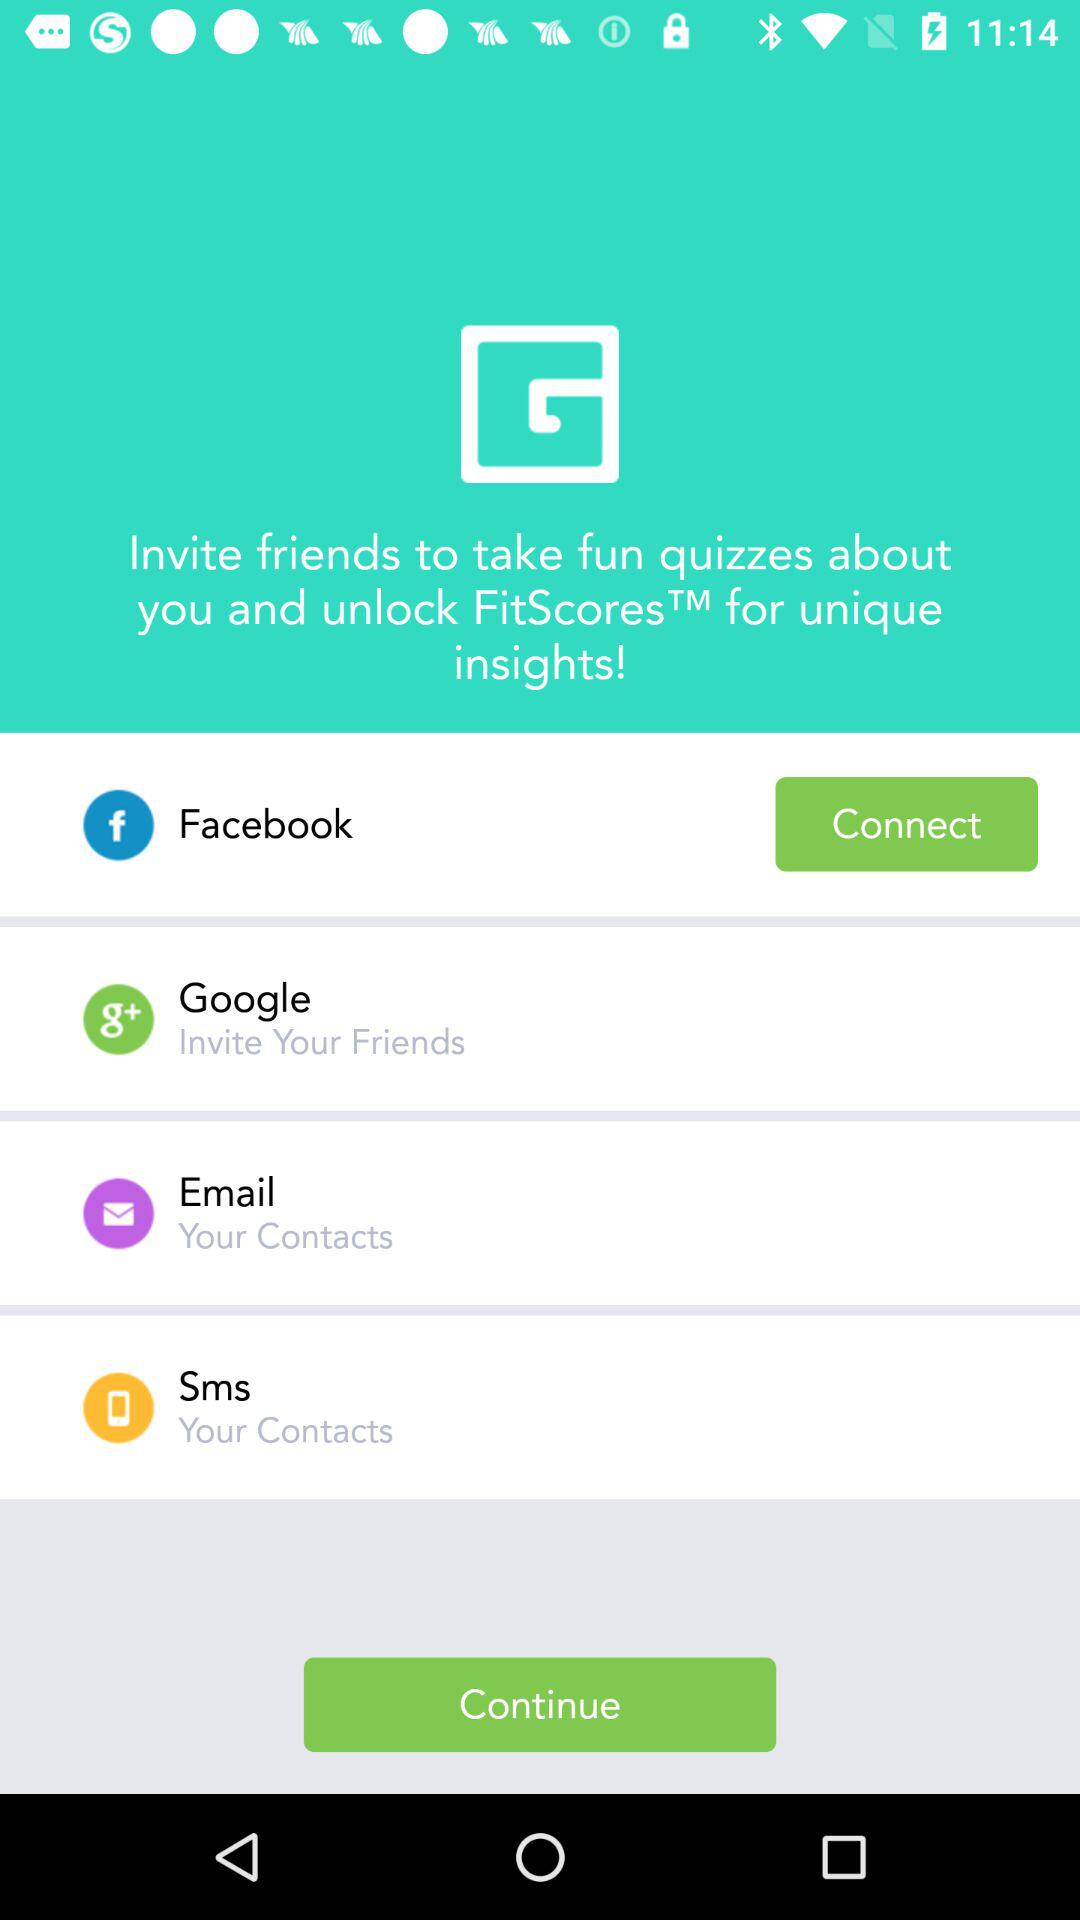Through which application can the users invite their friends? The users can invite their friends through "Google". 